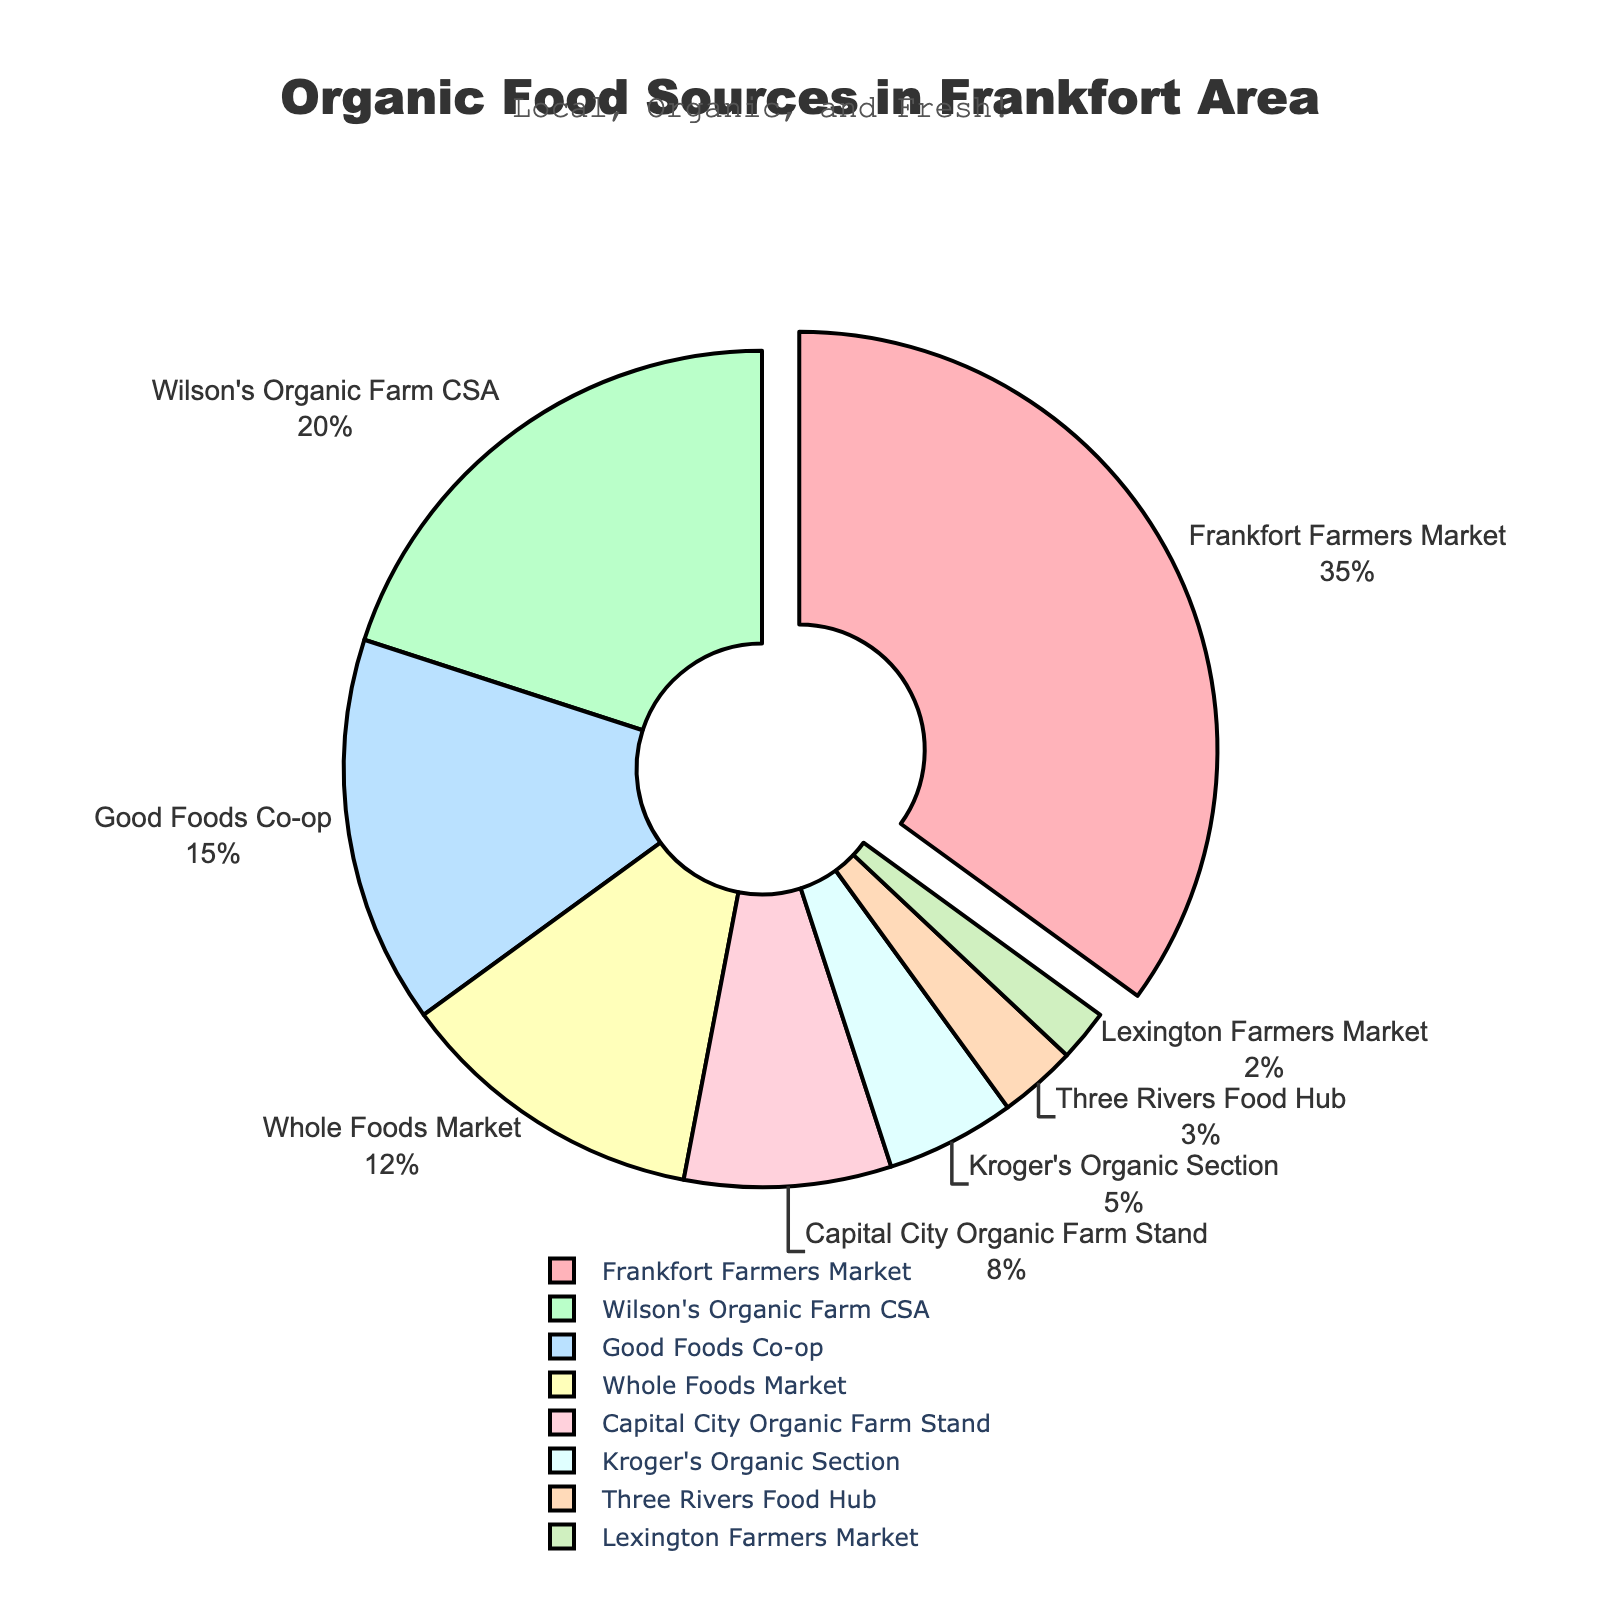What is the largest source of local organic food in the Frankfort area? The chart shows the breakdown of local organic food sources. The largest source is highlighted by being slightly pulled out from the pie chart.
Answer: Frankfort Farmers Market What percentage of local organic food comes from CSAs? Locate the part of the pie chart labeled "Wilson's Organic Farm CSA" and read the percentage.
Answer: 20% How does the percentage of local organic food from grocery stores compare to that from farmers markets? Identify the sum of the percentages from "Good Foods Co-op," "Whole Foods Market," and "Kroger's Organic Section" (15% + 12% + 5%) and compare it to the percentage from "Frankfort Farmers Market" (35%).
Answer: Grocery Stores: 32%, Farmers Markets: 35% What is the combined percentage of local organic food sourced from both farmers markets? Sum the percentages of "Frankfort Farmers Market" and "Lexington Farmers Market" (35% + 2%).
Answer: 37% Which source provides less than 5% of local organic food? Identify the sections of the pie chart with percentages less than 5%, specifically noting "Three Rivers Food Hub" and "Lexington Farmers Market."
Answer: Three Rivers Food Hub and Lexington Farmers Market How much more local organic produce is sourced from Good Foods Co-op compared to Three Rivers Food Hub? Subtract the percentage of "Three Rivers Food Hub" (3%) from "Good Foods Co-op" (15%).
Answer: 12% Is the combined percentage of Whole Foods Market and Capital City Organic Farm Stand greater or less than that of Wilson's Organic Farm CSA? Sum the percentages of "Whole Foods Market" and "Capital City Organic Farm Stand" (12% + 8%), then compare it to the percentage of "Wilson's Organic Farm CSA" (20%).
Answer: Equal (20%) What visual feature helps identify the largest source of local organic food on the pie chart? The section representing the Frankfort Farmers Market is slightly pulled out from the pie chart, making it visually distinct.
Answer: Pulled-out section Which source has a similar contribution to the combined total of Three Rivers Food Hub and Lexington Farmers Market? Add the percentages of "Three Rivers Food Hub" and "Lexington Farmers Market" (3% + 2%) and compare to individual sources. The combination is 5%, which matches "Kroger's Organic Section."
Answer: Kroger's Organic Section What is the smallest source of local organic food in the Frankfort area? According to the pie chart, the source with the smallest percentage is identified.
Answer: Lexington Farmers Market 